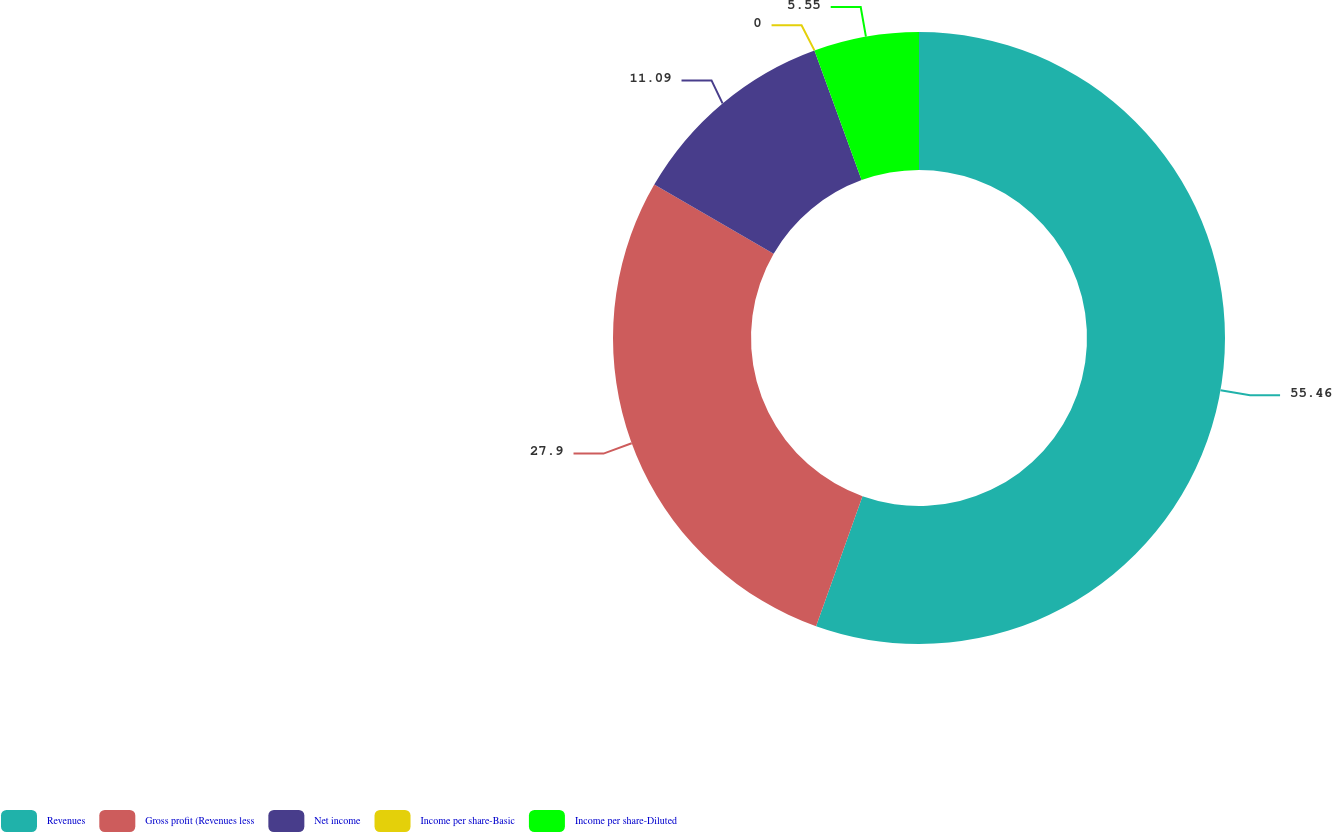Convert chart to OTSL. <chart><loc_0><loc_0><loc_500><loc_500><pie_chart><fcel>Revenues<fcel>Gross profit (Revenues less<fcel>Net income<fcel>Income per share-Basic<fcel>Income per share-Diluted<nl><fcel>55.46%<fcel>27.9%<fcel>11.09%<fcel>0.0%<fcel>5.55%<nl></chart> 